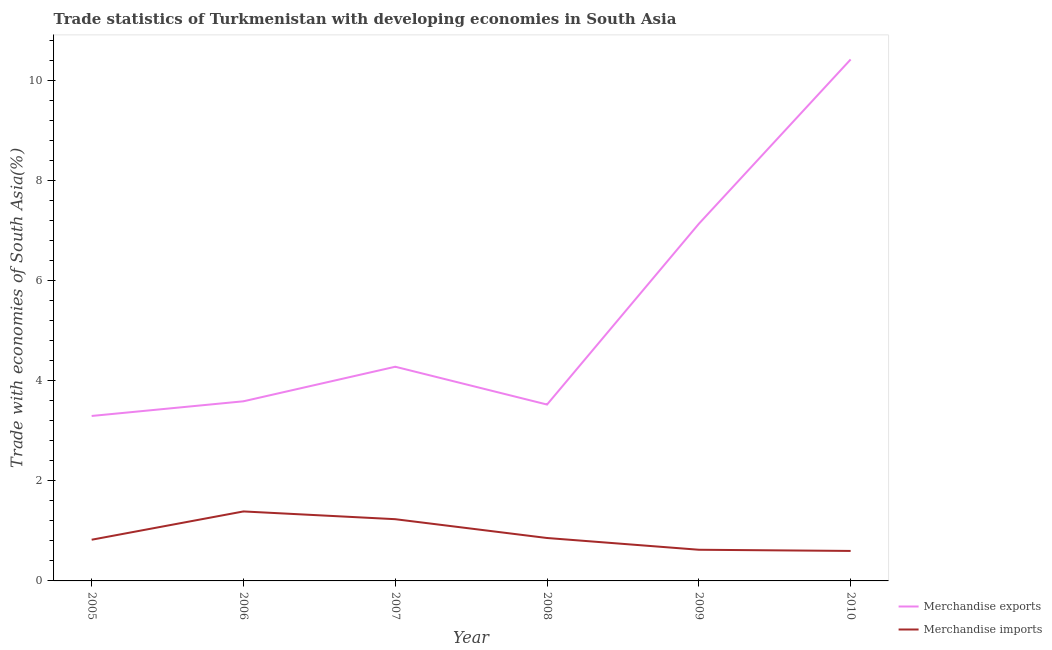How many different coloured lines are there?
Give a very brief answer. 2. Is the number of lines equal to the number of legend labels?
Offer a terse response. Yes. What is the merchandise imports in 2007?
Your response must be concise. 1.23. Across all years, what is the maximum merchandise exports?
Keep it short and to the point. 10.43. Across all years, what is the minimum merchandise imports?
Provide a short and direct response. 0.6. In which year was the merchandise exports minimum?
Keep it short and to the point. 2005. What is the total merchandise exports in the graph?
Offer a terse response. 32.26. What is the difference between the merchandise exports in 2005 and that in 2008?
Your answer should be compact. -0.23. What is the difference between the merchandise imports in 2010 and the merchandise exports in 2009?
Provide a short and direct response. -6.54. What is the average merchandise exports per year?
Keep it short and to the point. 5.38. In the year 2007, what is the difference between the merchandise imports and merchandise exports?
Offer a terse response. -3.05. What is the ratio of the merchandise exports in 2009 to that in 2010?
Provide a succinct answer. 0.68. Is the difference between the merchandise exports in 2006 and 2010 greater than the difference between the merchandise imports in 2006 and 2010?
Offer a terse response. No. What is the difference between the highest and the second highest merchandise exports?
Your answer should be compact. 3.29. What is the difference between the highest and the lowest merchandise imports?
Offer a very short reply. 0.79. In how many years, is the merchandise imports greater than the average merchandise imports taken over all years?
Make the answer very short. 2. Does the merchandise imports monotonically increase over the years?
Provide a short and direct response. No. Is the merchandise imports strictly greater than the merchandise exports over the years?
Your answer should be very brief. No. Is the merchandise exports strictly less than the merchandise imports over the years?
Offer a very short reply. No. How many lines are there?
Your answer should be very brief. 2. Does the graph contain grids?
Provide a succinct answer. No. Where does the legend appear in the graph?
Provide a succinct answer. Bottom right. How many legend labels are there?
Provide a short and direct response. 2. What is the title of the graph?
Provide a succinct answer. Trade statistics of Turkmenistan with developing economies in South Asia. Does "UN agencies" appear as one of the legend labels in the graph?
Give a very brief answer. No. What is the label or title of the X-axis?
Your answer should be compact. Year. What is the label or title of the Y-axis?
Ensure brevity in your answer.  Trade with economies of South Asia(%). What is the Trade with economies of South Asia(%) of Merchandise exports in 2005?
Provide a short and direct response. 3.3. What is the Trade with economies of South Asia(%) in Merchandise imports in 2005?
Your response must be concise. 0.82. What is the Trade with economies of South Asia(%) of Merchandise exports in 2006?
Provide a succinct answer. 3.59. What is the Trade with economies of South Asia(%) of Merchandise imports in 2006?
Your answer should be very brief. 1.39. What is the Trade with economies of South Asia(%) in Merchandise exports in 2007?
Make the answer very short. 4.28. What is the Trade with economies of South Asia(%) of Merchandise imports in 2007?
Offer a very short reply. 1.23. What is the Trade with economies of South Asia(%) of Merchandise exports in 2008?
Provide a succinct answer. 3.53. What is the Trade with economies of South Asia(%) of Merchandise imports in 2008?
Provide a succinct answer. 0.86. What is the Trade with economies of South Asia(%) of Merchandise exports in 2009?
Your answer should be very brief. 7.14. What is the Trade with economies of South Asia(%) in Merchandise imports in 2009?
Keep it short and to the point. 0.62. What is the Trade with economies of South Asia(%) of Merchandise exports in 2010?
Your answer should be very brief. 10.43. What is the Trade with economies of South Asia(%) in Merchandise imports in 2010?
Ensure brevity in your answer.  0.6. Across all years, what is the maximum Trade with economies of South Asia(%) in Merchandise exports?
Make the answer very short. 10.43. Across all years, what is the maximum Trade with economies of South Asia(%) in Merchandise imports?
Make the answer very short. 1.39. Across all years, what is the minimum Trade with economies of South Asia(%) in Merchandise exports?
Give a very brief answer. 3.3. Across all years, what is the minimum Trade with economies of South Asia(%) in Merchandise imports?
Ensure brevity in your answer.  0.6. What is the total Trade with economies of South Asia(%) in Merchandise exports in the graph?
Provide a succinct answer. 32.26. What is the total Trade with economies of South Asia(%) of Merchandise imports in the graph?
Your response must be concise. 5.53. What is the difference between the Trade with economies of South Asia(%) in Merchandise exports in 2005 and that in 2006?
Offer a terse response. -0.29. What is the difference between the Trade with economies of South Asia(%) in Merchandise imports in 2005 and that in 2006?
Give a very brief answer. -0.57. What is the difference between the Trade with economies of South Asia(%) of Merchandise exports in 2005 and that in 2007?
Your answer should be compact. -0.98. What is the difference between the Trade with economies of South Asia(%) in Merchandise imports in 2005 and that in 2007?
Your answer should be compact. -0.41. What is the difference between the Trade with economies of South Asia(%) in Merchandise exports in 2005 and that in 2008?
Provide a succinct answer. -0.23. What is the difference between the Trade with economies of South Asia(%) of Merchandise imports in 2005 and that in 2008?
Provide a succinct answer. -0.03. What is the difference between the Trade with economies of South Asia(%) of Merchandise exports in 2005 and that in 2009?
Your answer should be compact. -3.84. What is the difference between the Trade with economies of South Asia(%) in Merchandise imports in 2005 and that in 2009?
Give a very brief answer. 0.2. What is the difference between the Trade with economies of South Asia(%) of Merchandise exports in 2005 and that in 2010?
Provide a short and direct response. -7.13. What is the difference between the Trade with economies of South Asia(%) of Merchandise imports in 2005 and that in 2010?
Keep it short and to the point. 0.22. What is the difference between the Trade with economies of South Asia(%) of Merchandise exports in 2006 and that in 2007?
Keep it short and to the point. -0.69. What is the difference between the Trade with economies of South Asia(%) in Merchandise imports in 2006 and that in 2007?
Provide a succinct answer. 0.16. What is the difference between the Trade with economies of South Asia(%) in Merchandise exports in 2006 and that in 2008?
Your response must be concise. 0.07. What is the difference between the Trade with economies of South Asia(%) in Merchandise imports in 2006 and that in 2008?
Offer a very short reply. 0.53. What is the difference between the Trade with economies of South Asia(%) in Merchandise exports in 2006 and that in 2009?
Give a very brief answer. -3.55. What is the difference between the Trade with economies of South Asia(%) of Merchandise imports in 2006 and that in 2009?
Provide a short and direct response. 0.77. What is the difference between the Trade with economies of South Asia(%) in Merchandise exports in 2006 and that in 2010?
Make the answer very short. -6.83. What is the difference between the Trade with economies of South Asia(%) in Merchandise imports in 2006 and that in 2010?
Keep it short and to the point. 0.79. What is the difference between the Trade with economies of South Asia(%) in Merchandise exports in 2007 and that in 2008?
Your answer should be compact. 0.76. What is the difference between the Trade with economies of South Asia(%) in Merchandise imports in 2007 and that in 2008?
Your answer should be very brief. 0.38. What is the difference between the Trade with economies of South Asia(%) in Merchandise exports in 2007 and that in 2009?
Make the answer very short. -2.86. What is the difference between the Trade with economies of South Asia(%) in Merchandise imports in 2007 and that in 2009?
Offer a terse response. 0.61. What is the difference between the Trade with economies of South Asia(%) of Merchandise exports in 2007 and that in 2010?
Offer a very short reply. -6.14. What is the difference between the Trade with economies of South Asia(%) in Merchandise imports in 2007 and that in 2010?
Your answer should be very brief. 0.63. What is the difference between the Trade with economies of South Asia(%) of Merchandise exports in 2008 and that in 2009?
Your answer should be very brief. -3.61. What is the difference between the Trade with economies of South Asia(%) of Merchandise imports in 2008 and that in 2009?
Offer a very short reply. 0.23. What is the difference between the Trade with economies of South Asia(%) of Merchandise exports in 2008 and that in 2010?
Offer a terse response. -6.9. What is the difference between the Trade with economies of South Asia(%) in Merchandise imports in 2008 and that in 2010?
Give a very brief answer. 0.26. What is the difference between the Trade with economies of South Asia(%) of Merchandise exports in 2009 and that in 2010?
Keep it short and to the point. -3.29. What is the difference between the Trade with economies of South Asia(%) of Merchandise imports in 2009 and that in 2010?
Your answer should be very brief. 0.02. What is the difference between the Trade with economies of South Asia(%) in Merchandise exports in 2005 and the Trade with economies of South Asia(%) in Merchandise imports in 2006?
Provide a succinct answer. 1.91. What is the difference between the Trade with economies of South Asia(%) of Merchandise exports in 2005 and the Trade with economies of South Asia(%) of Merchandise imports in 2007?
Provide a short and direct response. 2.06. What is the difference between the Trade with economies of South Asia(%) of Merchandise exports in 2005 and the Trade with economies of South Asia(%) of Merchandise imports in 2008?
Your response must be concise. 2.44. What is the difference between the Trade with economies of South Asia(%) of Merchandise exports in 2005 and the Trade with economies of South Asia(%) of Merchandise imports in 2009?
Your response must be concise. 2.67. What is the difference between the Trade with economies of South Asia(%) of Merchandise exports in 2005 and the Trade with economies of South Asia(%) of Merchandise imports in 2010?
Your response must be concise. 2.7. What is the difference between the Trade with economies of South Asia(%) in Merchandise exports in 2006 and the Trade with economies of South Asia(%) in Merchandise imports in 2007?
Offer a very short reply. 2.36. What is the difference between the Trade with economies of South Asia(%) in Merchandise exports in 2006 and the Trade with economies of South Asia(%) in Merchandise imports in 2008?
Provide a short and direct response. 2.73. What is the difference between the Trade with economies of South Asia(%) of Merchandise exports in 2006 and the Trade with economies of South Asia(%) of Merchandise imports in 2009?
Keep it short and to the point. 2.97. What is the difference between the Trade with economies of South Asia(%) in Merchandise exports in 2006 and the Trade with economies of South Asia(%) in Merchandise imports in 2010?
Your response must be concise. 2.99. What is the difference between the Trade with economies of South Asia(%) of Merchandise exports in 2007 and the Trade with economies of South Asia(%) of Merchandise imports in 2008?
Your response must be concise. 3.42. What is the difference between the Trade with economies of South Asia(%) in Merchandise exports in 2007 and the Trade with economies of South Asia(%) in Merchandise imports in 2009?
Your answer should be compact. 3.66. What is the difference between the Trade with economies of South Asia(%) in Merchandise exports in 2007 and the Trade with economies of South Asia(%) in Merchandise imports in 2010?
Your answer should be very brief. 3.68. What is the difference between the Trade with economies of South Asia(%) of Merchandise exports in 2008 and the Trade with economies of South Asia(%) of Merchandise imports in 2009?
Your answer should be very brief. 2.9. What is the difference between the Trade with economies of South Asia(%) in Merchandise exports in 2008 and the Trade with economies of South Asia(%) in Merchandise imports in 2010?
Make the answer very short. 2.93. What is the difference between the Trade with economies of South Asia(%) in Merchandise exports in 2009 and the Trade with economies of South Asia(%) in Merchandise imports in 2010?
Offer a terse response. 6.54. What is the average Trade with economies of South Asia(%) of Merchandise exports per year?
Your answer should be very brief. 5.38. What is the average Trade with economies of South Asia(%) of Merchandise imports per year?
Provide a succinct answer. 0.92. In the year 2005, what is the difference between the Trade with economies of South Asia(%) of Merchandise exports and Trade with economies of South Asia(%) of Merchandise imports?
Your response must be concise. 2.47. In the year 2006, what is the difference between the Trade with economies of South Asia(%) of Merchandise exports and Trade with economies of South Asia(%) of Merchandise imports?
Offer a terse response. 2.2. In the year 2007, what is the difference between the Trade with economies of South Asia(%) in Merchandise exports and Trade with economies of South Asia(%) in Merchandise imports?
Ensure brevity in your answer.  3.05. In the year 2008, what is the difference between the Trade with economies of South Asia(%) of Merchandise exports and Trade with economies of South Asia(%) of Merchandise imports?
Give a very brief answer. 2.67. In the year 2009, what is the difference between the Trade with economies of South Asia(%) of Merchandise exports and Trade with economies of South Asia(%) of Merchandise imports?
Offer a very short reply. 6.52. In the year 2010, what is the difference between the Trade with economies of South Asia(%) of Merchandise exports and Trade with economies of South Asia(%) of Merchandise imports?
Your answer should be very brief. 9.83. What is the ratio of the Trade with economies of South Asia(%) in Merchandise exports in 2005 to that in 2006?
Your answer should be compact. 0.92. What is the ratio of the Trade with economies of South Asia(%) in Merchandise imports in 2005 to that in 2006?
Your answer should be compact. 0.59. What is the ratio of the Trade with economies of South Asia(%) in Merchandise exports in 2005 to that in 2007?
Make the answer very short. 0.77. What is the ratio of the Trade with economies of South Asia(%) of Merchandise imports in 2005 to that in 2007?
Your answer should be very brief. 0.67. What is the ratio of the Trade with economies of South Asia(%) in Merchandise exports in 2005 to that in 2008?
Your answer should be compact. 0.94. What is the ratio of the Trade with economies of South Asia(%) of Merchandise imports in 2005 to that in 2008?
Make the answer very short. 0.96. What is the ratio of the Trade with economies of South Asia(%) of Merchandise exports in 2005 to that in 2009?
Keep it short and to the point. 0.46. What is the ratio of the Trade with economies of South Asia(%) of Merchandise imports in 2005 to that in 2009?
Your answer should be compact. 1.32. What is the ratio of the Trade with economies of South Asia(%) in Merchandise exports in 2005 to that in 2010?
Give a very brief answer. 0.32. What is the ratio of the Trade with economies of South Asia(%) in Merchandise imports in 2005 to that in 2010?
Offer a very short reply. 1.37. What is the ratio of the Trade with economies of South Asia(%) in Merchandise exports in 2006 to that in 2007?
Provide a short and direct response. 0.84. What is the ratio of the Trade with economies of South Asia(%) of Merchandise imports in 2006 to that in 2007?
Give a very brief answer. 1.13. What is the ratio of the Trade with economies of South Asia(%) of Merchandise exports in 2006 to that in 2008?
Your answer should be compact. 1.02. What is the ratio of the Trade with economies of South Asia(%) of Merchandise imports in 2006 to that in 2008?
Offer a very short reply. 1.62. What is the ratio of the Trade with economies of South Asia(%) of Merchandise exports in 2006 to that in 2009?
Make the answer very short. 0.5. What is the ratio of the Trade with economies of South Asia(%) of Merchandise imports in 2006 to that in 2009?
Offer a terse response. 2.23. What is the ratio of the Trade with economies of South Asia(%) of Merchandise exports in 2006 to that in 2010?
Offer a terse response. 0.34. What is the ratio of the Trade with economies of South Asia(%) in Merchandise imports in 2006 to that in 2010?
Keep it short and to the point. 2.32. What is the ratio of the Trade with economies of South Asia(%) of Merchandise exports in 2007 to that in 2008?
Your answer should be compact. 1.21. What is the ratio of the Trade with economies of South Asia(%) of Merchandise imports in 2007 to that in 2008?
Provide a short and direct response. 1.44. What is the ratio of the Trade with economies of South Asia(%) in Merchandise exports in 2007 to that in 2009?
Ensure brevity in your answer.  0.6. What is the ratio of the Trade with economies of South Asia(%) of Merchandise imports in 2007 to that in 2009?
Your answer should be very brief. 1.98. What is the ratio of the Trade with economies of South Asia(%) in Merchandise exports in 2007 to that in 2010?
Ensure brevity in your answer.  0.41. What is the ratio of the Trade with economies of South Asia(%) in Merchandise imports in 2007 to that in 2010?
Ensure brevity in your answer.  2.06. What is the ratio of the Trade with economies of South Asia(%) of Merchandise exports in 2008 to that in 2009?
Your response must be concise. 0.49. What is the ratio of the Trade with economies of South Asia(%) of Merchandise imports in 2008 to that in 2009?
Your answer should be very brief. 1.38. What is the ratio of the Trade with economies of South Asia(%) in Merchandise exports in 2008 to that in 2010?
Offer a very short reply. 0.34. What is the ratio of the Trade with economies of South Asia(%) of Merchandise imports in 2008 to that in 2010?
Keep it short and to the point. 1.43. What is the ratio of the Trade with economies of South Asia(%) in Merchandise exports in 2009 to that in 2010?
Give a very brief answer. 0.68. What is the ratio of the Trade with economies of South Asia(%) in Merchandise imports in 2009 to that in 2010?
Offer a very short reply. 1.04. What is the difference between the highest and the second highest Trade with economies of South Asia(%) of Merchandise exports?
Your answer should be compact. 3.29. What is the difference between the highest and the second highest Trade with economies of South Asia(%) in Merchandise imports?
Provide a short and direct response. 0.16. What is the difference between the highest and the lowest Trade with economies of South Asia(%) in Merchandise exports?
Provide a short and direct response. 7.13. What is the difference between the highest and the lowest Trade with economies of South Asia(%) in Merchandise imports?
Make the answer very short. 0.79. 